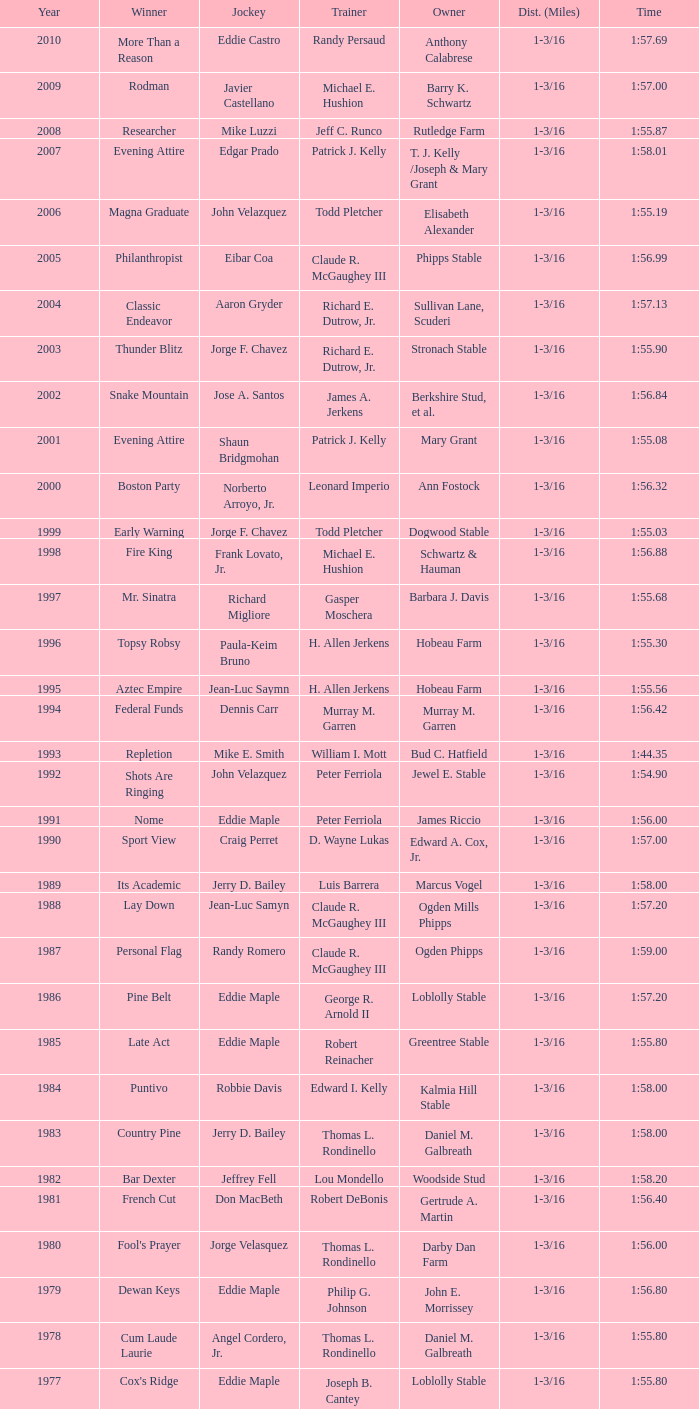Can you parse all the data within this table? {'header': ['Year', 'Winner', 'Jockey', 'Trainer', 'Owner', 'Dist. (Miles)', 'Time'], 'rows': [['2010', 'More Than a Reason', 'Eddie Castro', 'Randy Persaud', 'Anthony Calabrese', '1-3/16', '1:57.69'], ['2009', 'Rodman', 'Javier Castellano', 'Michael E. Hushion', 'Barry K. Schwartz', '1-3/16', '1:57.00'], ['2008', 'Researcher', 'Mike Luzzi', 'Jeff C. Runco', 'Rutledge Farm', '1-3/16', '1:55.87'], ['2007', 'Evening Attire', 'Edgar Prado', 'Patrick J. Kelly', 'T. J. Kelly /Joseph & Mary Grant', '1-3/16', '1:58.01'], ['2006', 'Magna Graduate', 'John Velazquez', 'Todd Pletcher', 'Elisabeth Alexander', '1-3/16', '1:55.19'], ['2005', 'Philanthropist', 'Eibar Coa', 'Claude R. McGaughey III', 'Phipps Stable', '1-3/16', '1:56.99'], ['2004', 'Classic Endeavor', 'Aaron Gryder', 'Richard E. Dutrow, Jr.', 'Sullivan Lane, Scuderi', '1-3/16', '1:57.13'], ['2003', 'Thunder Blitz', 'Jorge F. Chavez', 'Richard E. Dutrow, Jr.', 'Stronach Stable', '1-3/16', '1:55.90'], ['2002', 'Snake Mountain', 'Jose A. Santos', 'James A. Jerkens', 'Berkshire Stud, et al.', '1-3/16', '1:56.84'], ['2001', 'Evening Attire', 'Shaun Bridgmohan', 'Patrick J. Kelly', 'Mary Grant', '1-3/16', '1:55.08'], ['2000', 'Boston Party', 'Norberto Arroyo, Jr.', 'Leonard Imperio', 'Ann Fostock', '1-3/16', '1:56.32'], ['1999', 'Early Warning', 'Jorge F. Chavez', 'Todd Pletcher', 'Dogwood Stable', '1-3/16', '1:55.03'], ['1998', 'Fire King', 'Frank Lovato, Jr.', 'Michael E. Hushion', 'Schwartz & Hauman', '1-3/16', '1:56.88'], ['1997', 'Mr. Sinatra', 'Richard Migliore', 'Gasper Moschera', 'Barbara J. Davis', '1-3/16', '1:55.68'], ['1996', 'Topsy Robsy', 'Paula-Keim Bruno', 'H. Allen Jerkens', 'Hobeau Farm', '1-3/16', '1:55.30'], ['1995', 'Aztec Empire', 'Jean-Luc Saymn', 'H. Allen Jerkens', 'Hobeau Farm', '1-3/16', '1:55.56'], ['1994', 'Federal Funds', 'Dennis Carr', 'Murray M. Garren', 'Murray M. Garren', '1-3/16', '1:56.42'], ['1993', 'Repletion', 'Mike E. Smith', 'William I. Mott', 'Bud C. Hatfield', '1-3/16', '1:44.35'], ['1992', 'Shots Are Ringing', 'John Velazquez', 'Peter Ferriola', 'Jewel E. Stable', '1-3/16', '1:54.90'], ['1991', 'Nome', 'Eddie Maple', 'Peter Ferriola', 'James Riccio', '1-3/16', '1:56.00'], ['1990', 'Sport View', 'Craig Perret', 'D. Wayne Lukas', 'Edward A. Cox, Jr.', '1-3/16', '1:57.00'], ['1989', 'Its Academic', 'Jerry D. Bailey', 'Luis Barrera', 'Marcus Vogel', '1-3/16', '1:58.00'], ['1988', 'Lay Down', 'Jean-Luc Samyn', 'Claude R. McGaughey III', 'Ogden Mills Phipps', '1-3/16', '1:57.20'], ['1987', 'Personal Flag', 'Randy Romero', 'Claude R. McGaughey III', 'Ogden Phipps', '1-3/16', '1:59.00'], ['1986', 'Pine Belt', 'Eddie Maple', 'George R. Arnold II', 'Loblolly Stable', '1-3/16', '1:57.20'], ['1985', 'Late Act', 'Eddie Maple', 'Robert Reinacher', 'Greentree Stable', '1-3/16', '1:55.80'], ['1984', 'Puntivo', 'Robbie Davis', 'Edward I. Kelly', 'Kalmia Hill Stable', '1-3/16', '1:58.00'], ['1983', 'Country Pine', 'Jerry D. Bailey', 'Thomas L. Rondinello', 'Daniel M. Galbreath', '1-3/16', '1:58.00'], ['1982', 'Bar Dexter', 'Jeffrey Fell', 'Lou Mondello', 'Woodside Stud', '1-3/16', '1:58.20'], ['1981', 'French Cut', 'Don MacBeth', 'Robert DeBonis', 'Gertrude A. Martin', '1-3/16', '1:56.40'], ['1980', "Fool's Prayer", 'Jorge Velasquez', 'Thomas L. Rondinello', 'Darby Dan Farm', '1-3/16', '1:56.00'], ['1979', 'Dewan Keys', 'Eddie Maple', 'Philip G. Johnson', 'John E. Morrissey', '1-3/16', '1:56.80'], ['1978', 'Cum Laude Laurie', 'Angel Cordero, Jr.', 'Thomas L. Rondinello', 'Daniel M. Galbreath', '1-3/16', '1:55.80'], ['1977', "Cox's Ridge", 'Eddie Maple', 'Joseph B. Cantey', 'Loblolly Stable', '1-3/16', '1:55.80'], ['1976', "It's Freezing", 'Jacinto Vasquez', 'Anthony Basile', 'Bwamazon Farm', '1-3/16', '1:56.60'], ['1975', 'Hail The Pirates', 'Ron Turcotte', 'Thomas L. Rondinello', 'Daniel M. Galbreath', '1-3/16', '1:55.60'], ['1974', 'Free Hand', 'Jose Amy', 'Pancho Martin', 'Sigmund Sommer', '1-3/16', '1:55.00'], ['1973', 'True Knight', 'Angel Cordero, Jr.', 'Thomas L. Rondinello', 'Darby Dan Farm', '1-3/16', '1:55.00'], ['1972', 'Sunny And Mild', 'Michael Venezia', 'W. Preston King', 'Harry Rogosin', '1-3/16', '1:54.40'], ['1971', 'Red Reality', 'Jorge Velasquez', 'MacKenzie Miller', 'Cragwood Stables', '1-1/8', '1:49.60'], ['1970', 'Best Turn', 'Larry Adams', 'Reggie Cornell', 'Calumet Farm', '1-1/8', '1:50.00'], ['1969', 'Vif', 'Larry Adams', 'Clarence Meaux', 'Harvey Peltier', '1-1/8', '1:49.20'], ['1968', 'Irish Dude', 'Sandino Hernandez', 'Jack Bradley', 'Richard W. Taylor', '1-1/8', '1:49.60'], ['1967', 'Mr. Right', 'Heliodoro Gustines', 'Evan S. Jackson', 'Mrs. Peter Duchin', '1-1/8', '1:49.60'], ['1966', 'Amberoid', 'Walter Blum', 'Lucien Laurin', 'Reginald N. Webster', '1-1/8', '1:50.60'], ['1965', 'Prairie Schooner', 'Eddie Belmonte', 'James W. Smith', 'High Tide Stable', '1-1/8', '1:50.20'], ['1964', 'Third Martini', 'William Boland', 'H. Allen Jerkens', 'Hobeau Farm', '1-1/8', '1:50.60'], ['1963', 'Uppercut', 'Manuel Ycaza', 'Willard C. Freeman', 'William Harmonay', '1-1/8', '1:35.40'], ['1962', 'Grid Iron Hero', 'Manuel Ycaza', 'Laz Barrera', 'Emil Dolce', '1 mile', '1:34.00'], ['1961', 'Manassa Mauler', 'Braulio Baeza', 'Pancho Martin', 'Emil Dolce', '1 mile', '1:36.20'], ['1960', 'Cranberry Sauce', 'Heliodoro Gustines', 'not found', 'Elmendorf Farm', '1 mile', '1:36.20'], ['1959', 'Whitley', 'Eric Guerin', 'Max Hirsch', 'W. Arnold Hanger', '1 mile', '1:36.40'], ['1958', 'Oh Johnny', 'William Boland', 'Norman R. McLeod', 'Mrs. Wallace Gilroy', '1-1/16', '1:43.40'], ['1957', 'Bold Ruler', 'Eddie Arcaro', 'James E. Fitzsimmons', 'Wheatley Stable', '1-1/16', '1:42.80'], ['1956', 'Blessbull', 'Willie Lester', 'not found', 'Morris Sims', '1-1/16', '1:42.00'], ['1955', 'Fabulist', 'Ted Atkinson', 'William C. Winfrey', 'High Tide Stable', '1-1/16', '1:43.60'], ['1954', 'Find', 'Eric Guerin', 'William C. Winfrey', 'Alfred G. Vanderbilt II', '1-1/16', '1:44.00'], ['1953', 'Flaunt', 'S. Cole', 'Hubert W. Williams', 'Arnold Skjeveland', '1-1/16', '1:44.20'], ['1952', 'County Delight', 'Dave Gorman', 'James E. Ryan', 'Rokeby Stable', '1-1/16', '1:43.60'], ['1951', 'Sheilas Reward', 'Ovie Scurlock', 'Eugene Jacobs', 'Mrs. Louis Lazare', '1-1/16', '1:44.60'], ['1950', 'Three Rings', 'Hedley Woodhouse', 'Willie Knapp', 'Mrs. Evelyn L. Hopkins', '1-1/16', '1:44.60'], ['1949', 'Three Rings', 'Ted Atkinson', 'Willie Knapp', 'Mrs. Evelyn L. Hopkins', '1-1/16', '1:47.40'], ['1948', 'Knockdown', 'Ferrill Zufelt', 'Tom Smith', 'Maine Chance Farm', '1-1/16', '1:44.60'], ['1947', 'Gallorette', 'Job Dean Jessop', 'Edward A. Christmas', 'William L. Brann', '1-1/16', '1:45.40'], ['1946', 'Helioptic', 'Paul Miller', 'not found', 'William Goadby Loew', '1-1/16', '1:43.20'], ['1945', 'Olympic Zenith', 'Conn McCreary', 'Willie Booth', 'William G. Helis', '1-1/16', '1:45.60'], ['1944', 'First Fiddle', 'Johnny Longden', 'Edward Mulrenan', 'Mrs. Edward Mulrenan', '1-1/16', '1:44.20'], ['1943', 'The Rhymer', 'Conn McCreary', 'John M. Gaver, Sr.', 'Greentree Stable', '1-1/16', '1:45.00'], ['1942', 'Waller', 'Billie Thompson', 'A. G. Robertson', 'John C. Clark', '1-1/16', '1:44.00'], ['1941', 'Salford II', 'Don Meade', 'not found', 'Ralph B. Strassburger', '1-1/16', '1:44.20'], ['1940', 'He Did', 'Eddie Arcaro', 'J. Thomas Taylor', 'W. Arnold Hanger', '1-1/16', '1:43.20'], ['1939', 'Lovely Night', 'Johnny Longden', 'Henry McDaniel', 'Mrs. F. Ambrose Clark', '1 mile', '1:36.40'], ['1938', 'War Admiral', 'Charles Kurtsinger', 'George Conway', 'Glen Riddle Farm', '1 mile', '1:36.80'], ['1937', 'Snark', 'Johnny Longden', 'James E. Fitzsimmons', 'Wheatley Stable', '1 mile', '1:37.40'], ['1936', 'Good Gamble', 'Samuel Renick', 'Bud Stotler', 'Alfred G. Vanderbilt II', '1 mile', '1:37.20'], ['1935', 'King Saxon', 'Calvin Rainey', 'Charles Shaw', 'C. H. Knebelkamp', '1 mile', '1:37.20'], ['1934', 'Singing Wood', 'Robert Jones', 'James W. Healy', 'Liz Whitney', '1 mile', '1:38.60'], ['1933', 'Kerry Patch', 'Robert Wholey', 'Joseph A. Notter', 'Lee Rosenberg', '1 mile', '1:38.00'], ['1932', 'Halcyon', 'Hank Mills', 'T. J. Healey', 'C. V. Whitney', '1 mile', '1:38.00'], ['1931', 'Halcyon', 'G. Rose', 'T. J. Healey', 'C. V. Whitney', '1 mile', '1:38.40'], ['1930', 'Kildare', 'John Passero', 'Norman Tallman', 'Newtondale Stable', '1 mile', '1:38.60'], ['1929', 'Comstockery', 'Sidney Hebert', 'Thomas W. Murphy', 'Greentree Stable', '1 mile', '1:39.60'], ['1928', 'Kentucky II', 'George Schreiner', 'Max Hirsch', 'A. Charles Schwartz', '1 mile', '1:38.80'], ['1927', 'Light Carbine', 'James McCoy', 'M. J. Dunlevy', 'I. B. Humphreys', '1 mile', '1:36.80'], ['1926', 'Macaw', 'Linus McAtee', 'James G. Rowe, Sr.', 'Harry Payne Whitney', '1 mile', '1:37.00'], ['1925', 'Mad Play', 'Laverne Fator', 'Sam Hildreth', 'Rancocas Stable', '1 mile', '1:36.60'], ['1924', 'Mad Hatter', 'Earl Sande', 'Sam Hildreth', 'Rancocas Stable', '1 mile', '1:36.60'], ['1923', 'Zev', 'Earl Sande', 'Sam Hildreth', 'Rancocas Stable', '1 mile', '1:37.00'], ['1922', 'Grey Lag', 'Laverne Fator', 'Sam Hildreth', 'Rancocas Stable', '1 mile', '1:38.00'], ['1921', 'John P. Grier', 'Frank Keogh', 'James G. Rowe, Sr.', 'Harry Payne Whitney', '1 mile', '1:36.00'], ['1920', 'Cirrus', 'Lavelle Ensor', 'Sam Hildreth', 'Sam Hildreth', '1 mile', '1:38.00'], ['1919', 'Star Master', 'Merritt Buxton', 'Walter B. Jennings', 'A. Kingsley Macomber', '1 mile', '1:37.60'], ['1918', 'Roamer', 'Lawrence Lyke', 'A. J. Goldsborough', 'Andrew Miller', '1 mile', '1:36.60'], ['1917', 'Old Rosebud', 'Frank Robinson', 'Frank D. Weir', 'F. D. Weir & Hamilton C. Applegate', '1 mile', '1:37.60'], ['1916', 'Short Grass', 'Frank Keogh', 'not found', 'Emil Herz', '1 mile', '1:36.40'], ['1915', 'Roamer', 'James Butwell', 'A. J. Goldsborough', 'Andrew Miller', '1 mile', '1:39.20'], ['1914', 'Flying Fairy', 'Tommy Davies', 'J. Simon Healy', 'Edward B. Cassatt', '1 mile', '1:42.20'], ['1913', 'No Race', 'No Race', 'No Race', 'No Race', '1 mile', 'no race'], ['1912', 'No Race', 'No Race', 'No Race', 'No Race', '1 mile', 'no race'], ['1911', 'No Race', 'No Race', 'No Race', 'No Race', '1 mile', 'no race'], ['1910', 'Arasee', 'Buddy Glass', 'Andrew G. Blakely', 'Samuel Emery', '1 mile', '1:39.80'], ['1909', 'No Race', 'No Race', 'No Race', 'No Race', '1 mile', 'no race'], ['1908', 'Jack Atkin', 'Phil Musgrave', 'Herman R. Brandt', 'Barney Schreiber', '1 mile', '1:39.00'], ['1907', 'W. H. Carey', 'George Mountain', 'James Blute', 'Richard F. Carman', '1 mile', '1:40.00'], ['1906', "Ram's Horn", 'L. Perrine', 'W. S. "Jim" Williams', 'W. S. "Jim" Williams', '1 mile', '1:39.40'], ['1905', 'St. Valentine', 'William Crimmins', 'John Shields', 'Alexander Shields', '1 mile', '1:39.20'], ['1904', 'Rosetint', 'Thomas H. Burns', 'James Boden', 'John Boden', '1 mile', '1:39.20'], ['1903', 'Yellow Tail', 'Willie Shaw', 'H. E. Rowell', 'John Hackett', '1m 70yds', '1:45.20'], ['1902', 'Margravite', 'Otto Wonderly', 'not found', 'Charles Fleischmann Sons', '1m 70 yds', '1:46.00']]} What was the time for the winning horse Salford ii? 1:44.20. 